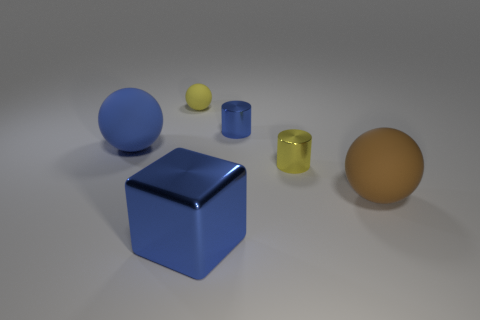There is a cylinder that is the same color as the small rubber thing; what is its size?
Offer a very short reply. Small. Do the yellow metal cylinder and the blue matte sphere have the same size?
Provide a succinct answer. No. The tiny yellow object behind the small cylinder that is behind the blue rubber sphere is made of what material?
Your answer should be very brief. Rubber. How many tiny cylinders are the same color as the tiny ball?
Your response must be concise. 1. Is there anything else that is the same material as the large brown thing?
Your response must be concise. Yes. Is the number of metallic objects that are behind the yellow matte sphere less than the number of tiny green shiny spheres?
Keep it short and to the point. No. The metallic object that is behind the small thing that is in front of the small blue shiny cylinder is what color?
Offer a terse response. Blue. How big is the rubber object that is on the left side of the yellow thing behind the small yellow thing that is in front of the small rubber object?
Ensure brevity in your answer.  Large. Are there fewer cubes on the left side of the large metal object than blue metallic cylinders to the right of the small yellow shiny thing?
Offer a terse response. No. How many large blue things are made of the same material as the big brown ball?
Your response must be concise. 1. 